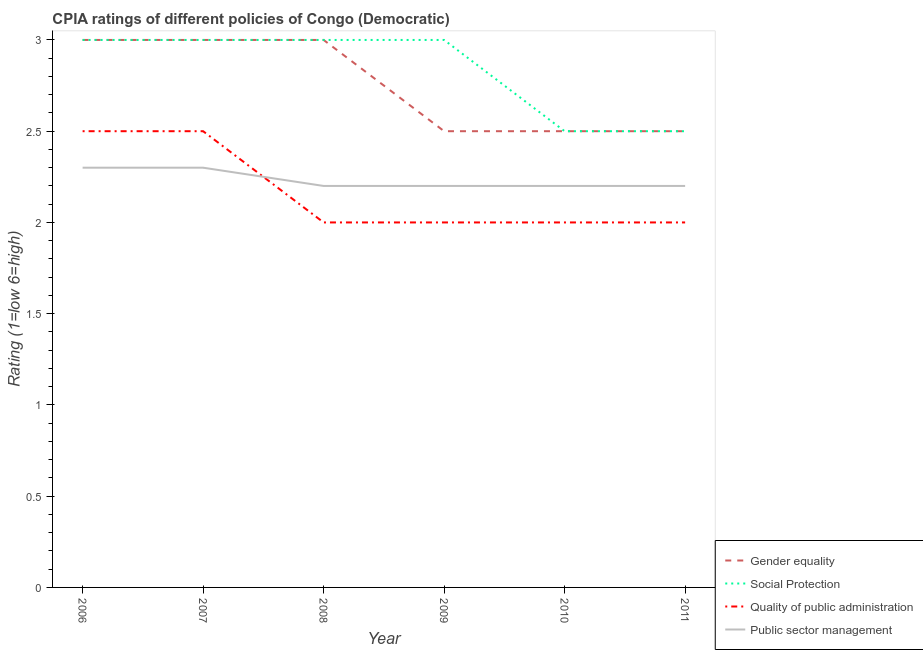How many different coloured lines are there?
Make the answer very short. 4. Does the line corresponding to cpia rating of gender equality intersect with the line corresponding to cpia rating of public sector management?
Offer a very short reply. No. Is the number of lines equal to the number of legend labels?
Your answer should be compact. Yes. What is the cpia rating of gender equality in 2009?
Provide a succinct answer. 2.5. Across all years, what is the maximum cpia rating of quality of public administration?
Provide a short and direct response. 2.5. Across all years, what is the minimum cpia rating of social protection?
Your response must be concise. 2.5. In which year was the cpia rating of public sector management minimum?
Provide a succinct answer. 2008. What is the difference between the cpia rating of public sector management in 2008 and that in 2011?
Keep it short and to the point. 0. What is the difference between the cpia rating of quality of public administration in 2007 and the cpia rating of gender equality in 2010?
Give a very brief answer. 0. What is the average cpia rating of social protection per year?
Offer a terse response. 2.83. In how many years, is the cpia rating of gender equality greater than 1.1?
Ensure brevity in your answer.  6. What is the ratio of the cpia rating of quality of public administration in 2008 to that in 2009?
Keep it short and to the point. 1. Is the cpia rating of social protection in 2006 less than that in 2009?
Ensure brevity in your answer.  No. Is the sum of the cpia rating of social protection in 2009 and 2010 greater than the maximum cpia rating of public sector management across all years?
Your answer should be compact. Yes. Is it the case that in every year, the sum of the cpia rating of gender equality and cpia rating of public sector management is greater than the sum of cpia rating of quality of public administration and cpia rating of social protection?
Provide a succinct answer. No. How many lines are there?
Offer a terse response. 4. How many years are there in the graph?
Provide a succinct answer. 6. Does the graph contain grids?
Your answer should be very brief. No. Where does the legend appear in the graph?
Offer a very short reply. Bottom right. What is the title of the graph?
Give a very brief answer. CPIA ratings of different policies of Congo (Democratic). Does "CO2 damage" appear as one of the legend labels in the graph?
Keep it short and to the point. No. What is the label or title of the Y-axis?
Your answer should be very brief. Rating (1=low 6=high). What is the Rating (1=low 6=high) of Gender equality in 2006?
Your answer should be very brief. 3. What is the Rating (1=low 6=high) of Quality of public administration in 2006?
Provide a short and direct response. 2.5. What is the Rating (1=low 6=high) in Public sector management in 2006?
Keep it short and to the point. 2.3. What is the Rating (1=low 6=high) of Gender equality in 2007?
Ensure brevity in your answer.  3. What is the Rating (1=low 6=high) of Quality of public administration in 2007?
Your answer should be very brief. 2.5. What is the Rating (1=low 6=high) in Gender equality in 2008?
Give a very brief answer. 3. What is the Rating (1=low 6=high) in Social Protection in 2008?
Keep it short and to the point. 3. What is the Rating (1=low 6=high) of Social Protection in 2009?
Give a very brief answer. 3. What is the Rating (1=low 6=high) in Public sector management in 2009?
Make the answer very short. 2.2. What is the Rating (1=low 6=high) of Gender equality in 2010?
Your response must be concise. 2.5. What is the Rating (1=low 6=high) of Social Protection in 2010?
Provide a succinct answer. 2.5. What is the Rating (1=low 6=high) in Quality of public administration in 2010?
Provide a short and direct response. 2. What is the Rating (1=low 6=high) in Public sector management in 2010?
Keep it short and to the point. 2.2. What is the Rating (1=low 6=high) in Gender equality in 2011?
Your response must be concise. 2.5. What is the Rating (1=low 6=high) of Quality of public administration in 2011?
Provide a short and direct response. 2. What is the Rating (1=low 6=high) of Public sector management in 2011?
Make the answer very short. 2.2. Across all years, what is the maximum Rating (1=low 6=high) in Quality of public administration?
Keep it short and to the point. 2.5. Across all years, what is the minimum Rating (1=low 6=high) of Gender equality?
Your answer should be compact. 2.5. Across all years, what is the minimum Rating (1=low 6=high) of Social Protection?
Provide a short and direct response. 2.5. Across all years, what is the minimum Rating (1=low 6=high) of Quality of public administration?
Keep it short and to the point. 2. What is the total Rating (1=low 6=high) of Social Protection in the graph?
Give a very brief answer. 17. What is the difference between the Rating (1=low 6=high) of Gender equality in 2006 and that in 2007?
Offer a very short reply. 0. What is the difference between the Rating (1=low 6=high) of Social Protection in 2006 and that in 2007?
Your answer should be very brief. 0. What is the difference between the Rating (1=low 6=high) in Quality of public administration in 2006 and that in 2007?
Your answer should be compact. 0. What is the difference between the Rating (1=low 6=high) in Public sector management in 2006 and that in 2007?
Give a very brief answer. 0. What is the difference between the Rating (1=low 6=high) in Social Protection in 2006 and that in 2008?
Keep it short and to the point. 0. What is the difference between the Rating (1=low 6=high) in Public sector management in 2006 and that in 2008?
Give a very brief answer. 0.1. What is the difference between the Rating (1=low 6=high) in Social Protection in 2006 and that in 2009?
Offer a very short reply. 0. What is the difference between the Rating (1=low 6=high) in Gender equality in 2006 and that in 2010?
Offer a very short reply. 0.5. What is the difference between the Rating (1=low 6=high) of Quality of public administration in 2006 and that in 2010?
Give a very brief answer. 0.5. What is the difference between the Rating (1=low 6=high) of Gender equality in 2006 and that in 2011?
Give a very brief answer. 0.5. What is the difference between the Rating (1=low 6=high) in Quality of public administration in 2006 and that in 2011?
Your response must be concise. 0.5. What is the difference between the Rating (1=low 6=high) of Gender equality in 2007 and that in 2008?
Ensure brevity in your answer.  0. What is the difference between the Rating (1=low 6=high) of Social Protection in 2007 and that in 2008?
Offer a very short reply. 0. What is the difference between the Rating (1=low 6=high) in Quality of public administration in 2007 and that in 2008?
Make the answer very short. 0.5. What is the difference between the Rating (1=low 6=high) of Public sector management in 2007 and that in 2010?
Offer a very short reply. 0.1. What is the difference between the Rating (1=low 6=high) in Gender equality in 2007 and that in 2011?
Give a very brief answer. 0.5. What is the difference between the Rating (1=low 6=high) in Quality of public administration in 2007 and that in 2011?
Keep it short and to the point. 0.5. What is the difference between the Rating (1=low 6=high) of Social Protection in 2008 and that in 2010?
Your answer should be compact. 0.5. What is the difference between the Rating (1=low 6=high) of Public sector management in 2008 and that in 2010?
Provide a succinct answer. 0. What is the difference between the Rating (1=low 6=high) of Gender equality in 2008 and that in 2011?
Provide a succinct answer. 0.5. What is the difference between the Rating (1=low 6=high) in Quality of public administration in 2008 and that in 2011?
Give a very brief answer. 0. What is the difference between the Rating (1=low 6=high) of Public sector management in 2008 and that in 2011?
Provide a succinct answer. 0. What is the difference between the Rating (1=low 6=high) in Gender equality in 2009 and that in 2011?
Give a very brief answer. 0. What is the difference between the Rating (1=low 6=high) of Public sector management in 2009 and that in 2011?
Your answer should be compact. 0. What is the difference between the Rating (1=low 6=high) in Gender equality in 2010 and that in 2011?
Provide a short and direct response. 0. What is the difference between the Rating (1=low 6=high) of Social Protection in 2010 and that in 2011?
Make the answer very short. 0. What is the difference between the Rating (1=low 6=high) of Quality of public administration in 2010 and that in 2011?
Your answer should be very brief. 0. What is the difference between the Rating (1=low 6=high) of Public sector management in 2010 and that in 2011?
Offer a very short reply. 0. What is the difference between the Rating (1=low 6=high) of Gender equality in 2006 and the Rating (1=low 6=high) of Social Protection in 2007?
Your answer should be very brief. 0. What is the difference between the Rating (1=low 6=high) of Gender equality in 2006 and the Rating (1=low 6=high) of Quality of public administration in 2007?
Offer a terse response. 0.5. What is the difference between the Rating (1=low 6=high) of Gender equality in 2006 and the Rating (1=low 6=high) of Public sector management in 2007?
Your response must be concise. 0.7. What is the difference between the Rating (1=low 6=high) in Gender equality in 2006 and the Rating (1=low 6=high) in Public sector management in 2008?
Your answer should be very brief. 0.8. What is the difference between the Rating (1=low 6=high) in Social Protection in 2006 and the Rating (1=low 6=high) in Quality of public administration in 2008?
Your answer should be very brief. 1. What is the difference between the Rating (1=low 6=high) of Social Protection in 2006 and the Rating (1=low 6=high) of Public sector management in 2008?
Provide a succinct answer. 0.8. What is the difference between the Rating (1=low 6=high) of Quality of public administration in 2006 and the Rating (1=low 6=high) of Public sector management in 2008?
Offer a very short reply. 0.3. What is the difference between the Rating (1=low 6=high) in Gender equality in 2006 and the Rating (1=low 6=high) in Social Protection in 2009?
Provide a succinct answer. 0. What is the difference between the Rating (1=low 6=high) in Quality of public administration in 2006 and the Rating (1=low 6=high) in Public sector management in 2009?
Your response must be concise. 0.3. What is the difference between the Rating (1=low 6=high) in Gender equality in 2006 and the Rating (1=low 6=high) in Quality of public administration in 2010?
Give a very brief answer. 1. What is the difference between the Rating (1=low 6=high) of Gender equality in 2006 and the Rating (1=low 6=high) of Public sector management in 2010?
Ensure brevity in your answer.  0.8. What is the difference between the Rating (1=low 6=high) in Social Protection in 2006 and the Rating (1=low 6=high) in Public sector management in 2010?
Provide a short and direct response. 0.8. What is the difference between the Rating (1=low 6=high) of Quality of public administration in 2006 and the Rating (1=low 6=high) of Public sector management in 2010?
Offer a very short reply. 0.3. What is the difference between the Rating (1=low 6=high) of Gender equality in 2006 and the Rating (1=low 6=high) of Social Protection in 2011?
Provide a succinct answer. 0.5. What is the difference between the Rating (1=low 6=high) in Gender equality in 2006 and the Rating (1=low 6=high) in Quality of public administration in 2011?
Keep it short and to the point. 1. What is the difference between the Rating (1=low 6=high) of Gender equality in 2006 and the Rating (1=low 6=high) of Public sector management in 2011?
Offer a very short reply. 0.8. What is the difference between the Rating (1=low 6=high) of Quality of public administration in 2006 and the Rating (1=low 6=high) of Public sector management in 2011?
Provide a short and direct response. 0.3. What is the difference between the Rating (1=low 6=high) in Gender equality in 2007 and the Rating (1=low 6=high) in Quality of public administration in 2008?
Provide a short and direct response. 1. What is the difference between the Rating (1=low 6=high) of Social Protection in 2007 and the Rating (1=low 6=high) of Quality of public administration in 2008?
Your answer should be compact. 1. What is the difference between the Rating (1=low 6=high) in Social Protection in 2007 and the Rating (1=low 6=high) in Public sector management in 2008?
Give a very brief answer. 0.8. What is the difference between the Rating (1=low 6=high) in Quality of public administration in 2007 and the Rating (1=low 6=high) in Public sector management in 2008?
Ensure brevity in your answer.  0.3. What is the difference between the Rating (1=low 6=high) of Gender equality in 2007 and the Rating (1=low 6=high) of Public sector management in 2009?
Give a very brief answer. 0.8. What is the difference between the Rating (1=low 6=high) in Social Protection in 2007 and the Rating (1=low 6=high) in Quality of public administration in 2009?
Your answer should be very brief. 1. What is the difference between the Rating (1=low 6=high) in Gender equality in 2007 and the Rating (1=low 6=high) in Public sector management in 2010?
Ensure brevity in your answer.  0.8. What is the difference between the Rating (1=low 6=high) of Social Protection in 2007 and the Rating (1=low 6=high) of Public sector management in 2010?
Offer a very short reply. 0.8. What is the difference between the Rating (1=low 6=high) of Quality of public administration in 2007 and the Rating (1=low 6=high) of Public sector management in 2010?
Your answer should be very brief. 0.3. What is the difference between the Rating (1=low 6=high) in Gender equality in 2007 and the Rating (1=low 6=high) in Social Protection in 2011?
Give a very brief answer. 0.5. What is the difference between the Rating (1=low 6=high) in Gender equality in 2007 and the Rating (1=low 6=high) in Quality of public administration in 2011?
Ensure brevity in your answer.  1. What is the difference between the Rating (1=low 6=high) of Gender equality in 2007 and the Rating (1=low 6=high) of Public sector management in 2011?
Offer a very short reply. 0.8. What is the difference between the Rating (1=low 6=high) of Social Protection in 2007 and the Rating (1=low 6=high) of Quality of public administration in 2011?
Provide a short and direct response. 1. What is the difference between the Rating (1=low 6=high) of Social Protection in 2007 and the Rating (1=low 6=high) of Public sector management in 2011?
Your response must be concise. 0.8. What is the difference between the Rating (1=low 6=high) of Gender equality in 2008 and the Rating (1=low 6=high) of Public sector management in 2009?
Ensure brevity in your answer.  0.8. What is the difference between the Rating (1=low 6=high) of Social Protection in 2008 and the Rating (1=low 6=high) of Quality of public administration in 2009?
Give a very brief answer. 1. What is the difference between the Rating (1=low 6=high) in Quality of public administration in 2008 and the Rating (1=low 6=high) in Public sector management in 2009?
Offer a terse response. -0.2. What is the difference between the Rating (1=low 6=high) in Gender equality in 2008 and the Rating (1=low 6=high) in Quality of public administration in 2010?
Give a very brief answer. 1. What is the difference between the Rating (1=low 6=high) of Gender equality in 2008 and the Rating (1=low 6=high) of Public sector management in 2010?
Provide a succinct answer. 0.8. What is the difference between the Rating (1=low 6=high) of Quality of public administration in 2008 and the Rating (1=low 6=high) of Public sector management in 2010?
Your answer should be compact. -0.2. What is the difference between the Rating (1=low 6=high) in Quality of public administration in 2008 and the Rating (1=low 6=high) in Public sector management in 2011?
Offer a terse response. -0.2. What is the difference between the Rating (1=low 6=high) in Gender equality in 2009 and the Rating (1=low 6=high) in Social Protection in 2010?
Provide a succinct answer. 0. What is the difference between the Rating (1=low 6=high) of Gender equality in 2009 and the Rating (1=low 6=high) of Quality of public administration in 2010?
Make the answer very short. 0.5. What is the difference between the Rating (1=low 6=high) of Social Protection in 2009 and the Rating (1=low 6=high) of Quality of public administration in 2010?
Ensure brevity in your answer.  1. What is the difference between the Rating (1=low 6=high) of Gender equality in 2009 and the Rating (1=low 6=high) of Public sector management in 2011?
Your response must be concise. 0.3. What is the difference between the Rating (1=low 6=high) in Social Protection in 2009 and the Rating (1=low 6=high) in Quality of public administration in 2011?
Make the answer very short. 1. What is the difference between the Rating (1=low 6=high) in Social Protection in 2009 and the Rating (1=low 6=high) in Public sector management in 2011?
Provide a succinct answer. 0.8. What is the difference between the Rating (1=low 6=high) in Gender equality in 2010 and the Rating (1=low 6=high) in Quality of public administration in 2011?
Make the answer very short. 0.5. What is the difference between the Rating (1=low 6=high) of Social Protection in 2010 and the Rating (1=low 6=high) of Quality of public administration in 2011?
Your answer should be compact. 0.5. What is the average Rating (1=low 6=high) of Gender equality per year?
Your answer should be compact. 2.75. What is the average Rating (1=low 6=high) of Social Protection per year?
Offer a terse response. 2.83. What is the average Rating (1=low 6=high) in Quality of public administration per year?
Provide a short and direct response. 2.17. What is the average Rating (1=low 6=high) in Public sector management per year?
Make the answer very short. 2.23. In the year 2006, what is the difference between the Rating (1=low 6=high) in Gender equality and Rating (1=low 6=high) in Social Protection?
Keep it short and to the point. 0. In the year 2006, what is the difference between the Rating (1=low 6=high) of Gender equality and Rating (1=low 6=high) of Quality of public administration?
Keep it short and to the point. 0.5. In the year 2006, what is the difference between the Rating (1=low 6=high) in Quality of public administration and Rating (1=low 6=high) in Public sector management?
Offer a terse response. 0.2. In the year 2007, what is the difference between the Rating (1=low 6=high) in Gender equality and Rating (1=low 6=high) in Social Protection?
Offer a very short reply. 0. In the year 2007, what is the difference between the Rating (1=low 6=high) of Gender equality and Rating (1=low 6=high) of Quality of public administration?
Keep it short and to the point. 0.5. In the year 2007, what is the difference between the Rating (1=low 6=high) of Gender equality and Rating (1=low 6=high) of Public sector management?
Make the answer very short. 0.7. In the year 2007, what is the difference between the Rating (1=low 6=high) in Quality of public administration and Rating (1=low 6=high) in Public sector management?
Your answer should be very brief. 0.2. In the year 2008, what is the difference between the Rating (1=low 6=high) in Gender equality and Rating (1=low 6=high) in Social Protection?
Keep it short and to the point. 0. In the year 2008, what is the difference between the Rating (1=low 6=high) of Gender equality and Rating (1=low 6=high) of Quality of public administration?
Your answer should be compact. 1. In the year 2008, what is the difference between the Rating (1=low 6=high) of Gender equality and Rating (1=low 6=high) of Public sector management?
Offer a terse response. 0.8. In the year 2008, what is the difference between the Rating (1=low 6=high) of Quality of public administration and Rating (1=low 6=high) of Public sector management?
Offer a terse response. -0.2. In the year 2009, what is the difference between the Rating (1=low 6=high) of Gender equality and Rating (1=low 6=high) of Social Protection?
Make the answer very short. -0.5. In the year 2009, what is the difference between the Rating (1=low 6=high) in Gender equality and Rating (1=low 6=high) in Quality of public administration?
Your response must be concise. 0.5. In the year 2010, what is the difference between the Rating (1=low 6=high) of Gender equality and Rating (1=low 6=high) of Quality of public administration?
Make the answer very short. 0.5. In the year 2010, what is the difference between the Rating (1=low 6=high) of Gender equality and Rating (1=low 6=high) of Public sector management?
Provide a short and direct response. 0.3. In the year 2010, what is the difference between the Rating (1=low 6=high) of Social Protection and Rating (1=low 6=high) of Quality of public administration?
Keep it short and to the point. 0.5. In the year 2010, what is the difference between the Rating (1=low 6=high) of Social Protection and Rating (1=low 6=high) of Public sector management?
Your answer should be compact. 0.3. In the year 2011, what is the difference between the Rating (1=low 6=high) in Gender equality and Rating (1=low 6=high) in Public sector management?
Ensure brevity in your answer.  0.3. In the year 2011, what is the difference between the Rating (1=low 6=high) in Social Protection and Rating (1=low 6=high) in Public sector management?
Keep it short and to the point. 0.3. What is the ratio of the Rating (1=low 6=high) in Social Protection in 2006 to that in 2007?
Offer a very short reply. 1. What is the ratio of the Rating (1=low 6=high) of Public sector management in 2006 to that in 2007?
Provide a succinct answer. 1. What is the ratio of the Rating (1=low 6=high) in Gender equality in 2006 to that in 2008?
Offer a terse response. 1. What is the ratio of the Rating (1=low 6=high) in Public sector management in 2006 to that in 2008?
Your response must be concise. 1.05. What is the ratio of the Rating (1=low 6=high) of Gender equality in 2006 to that in 2009?
Make the answer very short. 1.2. What is the ratio of the Rating (1=low 6=high) in Quality of public administration in 2006 to that in 2009?
Make the answer very short. 1.25. What is the ratio of the Rating (1=low 6=high) in Public sector management in 2006 to that in 2009?
Offer a terse response. 1.05. What is the ratio of the Rating (1=low 6=high) in Public sector management in 2006 to that in 2010?
Your answer should be compact. 1.05. What is the ratio of the Rating (1=low 6=high) of Social Protection in 2006 to that in 2011?
Provide a short and direct response. 1.2. What is the ratio of the Rating (1=low 6=high) in Quality of public administration in 2006 to that in 2011?
Make the answer very short. 1.25. What is the ratio of the Rating (1=low 6=high) in Public sector management in 2006 to that in 2011?
Keep it short and to the point. 1.05. What is the ratio of the Rating (1=low 6=high) of Gender equality in 2007 to that in 2008?
Give a very brief answer. 1. What is the ratio of the Rating (1=low 6=high) in Social Protection in 2007 to that in 2008?
Your response must be concise. 1. What is the ratio of the Rating (1=low 6=high) in Public sector management in 2007 to that in 2008?
Offer a terse response. 1.05. What is the ratio of the Rating (1=low 6=high) in Gender equality in 2007 to that in 2009?
Provide a succinct answer. 1.2. What is the ratio of the Rating (1=low 6=high) of Social Protection in 2007 to that in 2009?
Provide a short and direct response. 1. What is the ratio of the Rating (1=low 6=high) in Public sector management in 2007 to that in 2009?
Give a very brief answer. 1.05. What is the ratio of the Rating (1=low 6=high) in Gender equality in 2007 to that in 2010?
Provide a succinct answer. 1.2. What is the ratio of the Rating (1=low 6=high) in Public sector management in 2007 to that in 2010?
Your response must be concise. 1.05. What is the ratio of the Rating (1=low 6=high) of Gender equality in 2007 to that in 2011?
Offer a very short reply. 1.2. What is the ratio of the Rating (1=low 6=high) of Quality of public administration in 2007 to that in 2011?
Keep it short and to the point. 1.25. What is the ratio of the Rating (1=low 6=high) of Public sector management in 2007 to that in 2011?
Make the answer very short. 1.05. What is the ratio of the Rating (1=low 6=high) in Social Protection in 2008 to that in 2009?
Provide a succinct answer. 1. What is the ratio of the Rating (1=low 6=high) of Quality of public administration in 2008 to that in 2009?
Give a very brief answer. 1. What is the ratio of the Rating (1=low 6=high) of Quality of public administration in 2008 to that in 2010?
Offer a very short reply. 1. What is the ratio of the Rating (1=low 6=high) of Public sector management in 2008 to that in 2010?
Make the answer very short. 1. What is the ratio of the Rating (1=low 6=high) of Social Protection in 2009 to that in 2011?
Ensure brevity in your answer.  1.2. What is the ratio of the Rating (1=low 6=high) of Quality of public administration in 2009 to that in 2011?
Provide a succinct answer. 1. What is the ratio of the Rating (1=low 6=high) in Public sector management in 2009 to that in 2011?
Keep it short and to the point. 1. What is the ratio of the Rating (1=low 6=high) in Gender equality in 2010 to that in 2011?
Provide a succinct answer. 1. What is the ratio of the Rating (1=low 6=high) of Social Protection in 2010 to that in 2011?
Provide a short and direct response. 1. What is the ratio of the Rating (1=low 6=high) of Public sector management in 2010 to that in 2011?
Keep it short and to the point. 1. What is the difference between the highest and the second highest Rating (1=low 6=high) in Quality of public administration?
Provide a succinct answer. 0. What is the difference between the highest and the second highest Rating (1=low 6=high) of Public sector management?
Offer a very short reply. 0. What is the difference between the highest and the lowest Rating (1=low 6=high) of Gender equality?
Your response must be concise. 0.5. What is the difference between the highest and the lowest Rating (1=low 6=high) of Quality of public administration?
Your answer should be compact. 0.5. What is the difference between the highest and the lowest Rating (1=low 6=high) in Public sector management?
Keep it short and to the point. 0.1. 